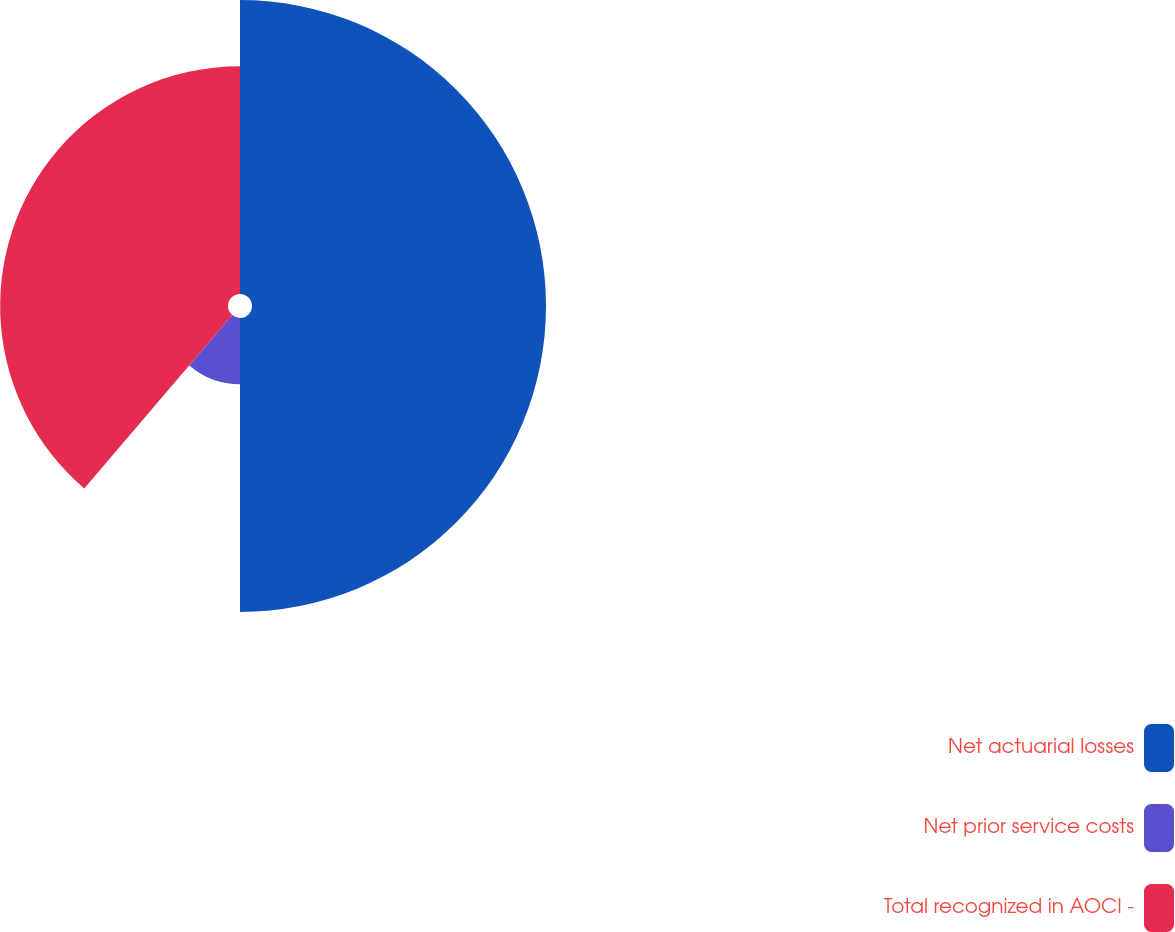Convert chart. <chart><loc_0><loc_0><loc_500><loc_500><pie_chart><fcel>Net actuarial losses<fcel>Net prior service costs<fcel>Total recognized in AOCI -<nl><fcel>50.0%<fcel>11.25%<fcel>38.75%<nl></chart> 